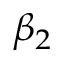<formula> <loc_0><loc_0><loc_500><loc_500>\beta _ { 2 }</formula> 